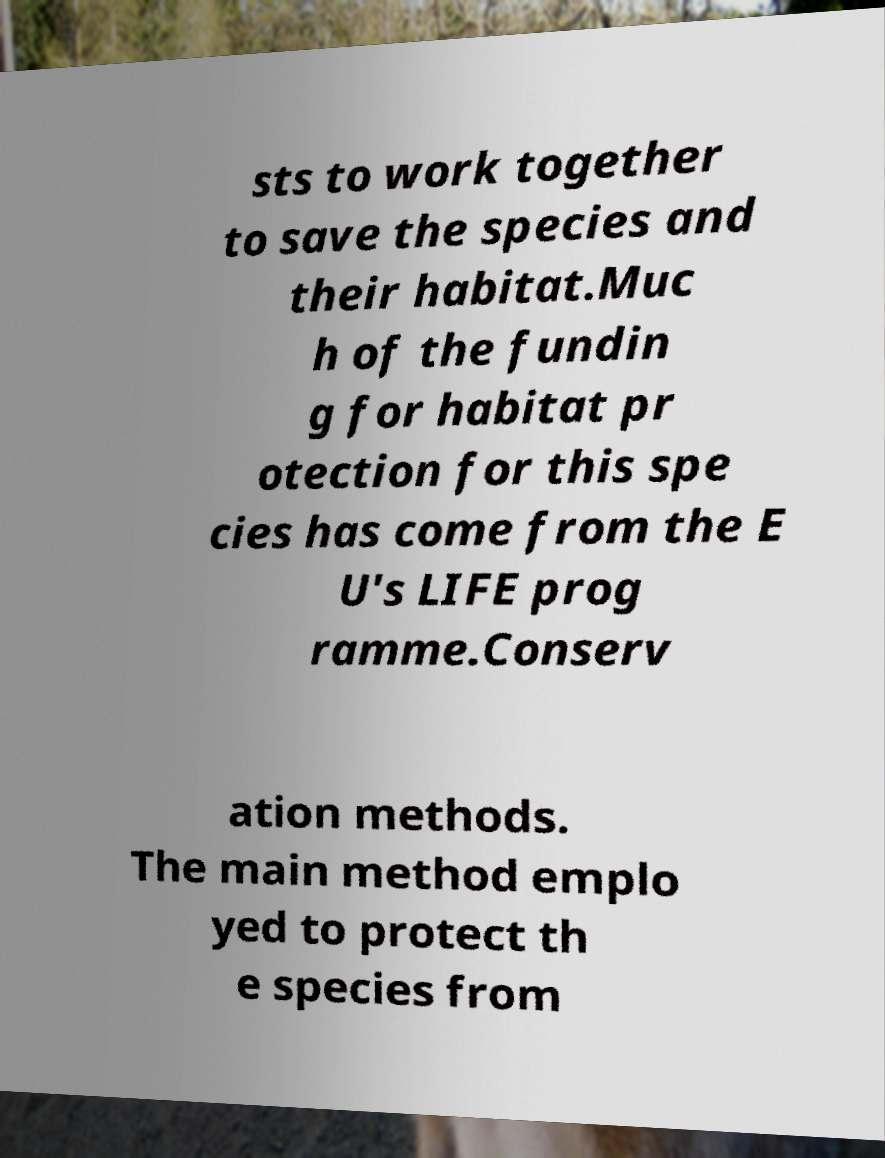I need the written content from this picture converted into text. Can you do that? sts to work together to save the species and their habitat.Muc h of the fundin g for habitat pr otection for this spe cies has come from the E U's LIFE prog ramme.Conserv ation methods. The main method emplo yed to protect th e species from 